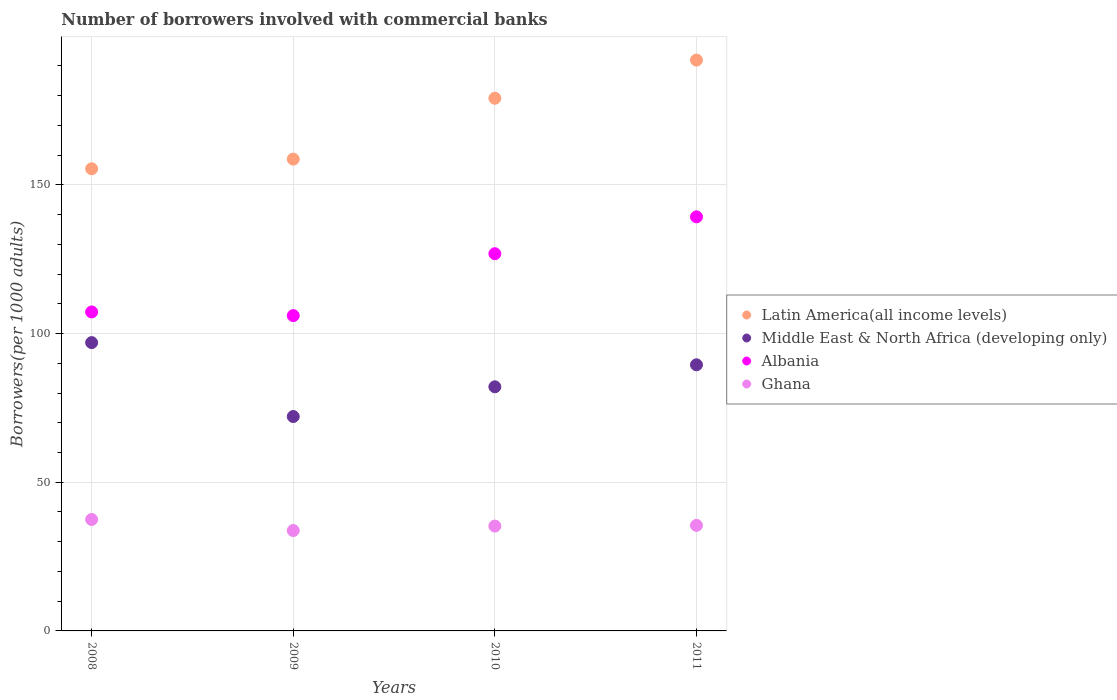How many different coloured dotlines are there?
Make the answer very short. 4. Is the number of dotlines equal to the number of legend labels?
Your response must be concise. Yes. What is the number of borrowers involved with commercial banks in Albania in 2011?
Your response must be concise. 139.27. Across all years, what is the maximum number of borrowers involved with commercial banks in Middle East & North Africa (developing only)?
Ensure brevity in your answer.  96.96. Across all years, what is the minimum number of borrowers involved with commercial banks in Middle East & North Africa (developing only)?
Offer a terse response. 72.11. What is the total number of borrowers involved with commercial banks in Middle East & North Africa (developing only) in the graph?
Make the answer very short. 340.67. What is the difference between the number of borrowers involved with commercial banks in Ghana in 2008 and that in 2011?
Offer a terse response. 1.98. What is the difference between the number of borrowers involved with commercial banks in Albania in 2010 and the number of borrowers involved with commercial banks in Latin America(all income levels) in 2009?
Make the answer very short. -31.82. What is the average number of borrowers involved with commercial banks in Ghana per year?
Your response must be concise. 35.5. In the year 2011, what is the difference between the number of borrowers involved with commercial banks in Albania and number of borrowers involved with commercial banks in Middle East & North Africa (developing only)?
Make the answer very short. 49.77. What is the ratio of the number of borrowers involved with commercial banks in Ghana in 2010 to that in 2011?
Ensure brevity in your answer.  0.99. Is the difference between the number of borrowers involved with commercial banks in Albania in 2010 and 2011 greater than the difference between the number of borrowers involved with commercial banks in Middle East & North Africa (developing only) in 2010 and 2011?
Provide a short and direct response. No. What is the difference between the highest and the second highest number of borrowers involved with commercial banks in Middle East & North Africa (developing only)?
Your answer should be compact. 7.46. What is the difference between the highest and the lowest number of borrowers involved with commercial banks in Latin America(all income levels)?
Your answer should be very brief. 36.55. In how many years, is the number of borrowers involved with commercial banks in Ghana greater than the average number of borrowers involved with commercial banks in Ghana taken over all years?
Offer a terse response. 1. Is it the case that in every year, the sum of the number of borrowers involved with commercial banks in Albania and number of borrowers involved with commercial banks in Latin America(all income levels)  is greater than the number of borrowers involved with commercial banks in Ghana?
Provide a short and direct response. Yes. Is the number of borrowers involved with commercial banks in Middle East & North Africa (developing only) strictly greater than the number of borrowers involved with commercial banks in Ghana over the years?
Ensure brevity in your answer.  Yes. Is the number of borrowers involved with commercial banks in Latin America(all income levels) strictly less than the number of borrowers involved with commercial banks in Ghana over the years?
Provide a short and direct response. No. What is the title of the graph?
Your response must be concise. Number of borrowers involved with commercial banks. What is the label or title of the Y-axis?
Your answer should be very brief. Borrowers(per 1000 adults). What is the Borrowers(per 1000 adults) in Latin America(all income levels) in 2008?
Your response must be concise. 155.43. What is the Borrowers(per 1000 adults) in Middle East & North Africa (developing only) in 2008?
Offer a very short reply. 96.96. What is the Borrowers(per 1000 adults) in Albania in 2008?
Your response must be concise. 107.27. What is the Borrowers(per 1000 adults) in Ghana in 2008?
Ensure brevity in your answer.  37.48. What is the Borrowers(per 1000 adults) in Latin America(all income levels) in 2009?
Offer a very short reply. 158.68. What is the Borrowers(per 1000 adults) of Middle East & North Africa (developing only) in 2009?
Give a very brief answer. 72.11. What is the Borrowers(per 1000 adults) of Albania in 2009?
Your answer should be very brief. 106.05. What is the Borrowers(per 1000 adults) of Ghana in 2009?
Your answer should be compact. 33.76. What is the Borrowers(per 1000 adults) in Latin America(all income levels) in 2010?
Your answer should be compact. 179.15. What is the Borrowers(per 1000 adults) in Middle East & North Africa (developing only) in 2010?
Give a very brief answer. 82.1. What is the Borrowers(per 1000 adults) of Albania in 2010?
Give a very brief answer. 126.87. What is the Borrowers(per 1000 adults) in Ghana in 2010?
Provide a succinct answer. 35.26. What is the Borrowers(per 1000 adults) of Latin America(all income levels) in 2011?
Ensure brevity in your answer.  191.98. What is the Borrowers(per 1000 adults) of Middle East & North Africa (developing only) in 2011?
Give a very brief answer. 89.5. What is the Borrowers(per 1000 adults) of Albania in 2011?
Give a very brief answer. 139.27. What is the Borrowers(per 1000 adults) of Ghana in 2011?
Ensure brevity in your answer.  35.5. Across all years, what is the maximum Borrowers(per 1000 adults) in Latin America(all income levels)?
Keep it short and to the point. 191.98. Across all years, what is the maximum Borrowers(per 1000 adults) in Middle East & North Africa (developing only)?
Your answer should be compact. 96.96. Across all years, what is the maximum Borrowers(per 1000 adults) in Albania?
Give a very brief answer. 139.27. Across all years, what is the maximum Borrowers(per 1000 adults) of Ghana?
Your answer should be very brief. 37.48. Across all years, what is the minimum Borrowers(per 1000 adults) in Latin America(all income levels)?
Keep it short and to the point. 155.43. Across all years, what is the minimum Borrowers(per 1000 adults) in Middle East & North Africa (developing only)?
Give a very brief answer. 72.11. Across all years, what is the minimum Borrowers(per 1000 adults) in Albania?
Provide a succinct answer. 106.05. Across all years, what is the minimum Borrowers(per 1000 adults) of Ghana?
Give a very brief answer. 33.76. What is the total Borrowers(per 1000 adults) of Latin America(all income levels) in the graph?
Give a very brief answer. 685.25. What is the total Borrowers(per 1000 adults) of Middle East & North Africa (developing only) in the graph?
Offer a terse response. 340.67. What is the total Borrowers(per 1000 adults) in Albania in the graph?
Provide a succinct answer. 479.45. What is the total Borrowers(per 1000 adults) in Ghana in the graph?
Offer a terse response. 142. What is the difference between the Borrowers(per 1000 adults) of Latin America(all income levels) in 2008 and that in 2009?
Your answer should be compact. -3.25. What is the difference between the Borrowers(per 1000 adults) of Middle East & North Africa (developing only) in 2008 and that in 2009?
Your answer should be compact. 24.86. What is the difference between the Borrowers(per 1000 adults) in Albania in 2008 and that in 2009?
Give a very brief answer. 1.23. What is the difference between the Borrowers(per 1000 adults) in Ghana in 2008 and that in 2009?
Offer a terse response. 3.72. What is the difference between the Borrowers(per 1000 adults) in Latin America(all income levels) in 2008 and that in 2010?
Your answer should be very brief. -23.72. What is the difference between the Borrowers(per 1000 adults) in Middle East & North Africa (developing only) in 2008 and that in 2010?
Offer a very short reply. 14.86. What is the difference between the Borrowers(per 1000 adults) in Albania in 2008 and that in 2010?
Your answer should be very brief. -19.59. What is the difference between the Borrowers(per 1000 adults) in Ghana in 2008 and that in 2010?
Make the answer very short. 2.22. What is the difference between the Borrowers(per 1000 adults) of Latin America(all income levels) in 2008 and that in 2011?
Provide a short and direct response. -36.55. What is the difference between the Borrowers(per 1000 adults) in Middle East & North Africa (developing only) in 2008 and that in 2011?
Your answer should be very brief. 7.46. What is the difference between the Borrowers(per 1000 adults) of Albania in 2008 and that in 2011?
Provide a short and direct response. -31.99. What is the difference between the Borrowers(per 1000 adults) in Ghana in 2008 and that in 2011?
Make the answer very short. 1.98. What is the difference between the Borrowers(per 1000 adults) in Latin America(all income levels) in 2009 and that in 2010?
Ensure brevity in your answer.  -20.47. What is the difference between the Borrowers(per 1000 adults) of Middle East & North Africa (developing only) in 2009 and that in 2010?
Make the answer very short. -10. What is the difference between the Borrowers(per 1000 adults) of Albania in 2009 and that in 2010?
Your answer should be compact. -20.82. What is the difference between the Borrowers(per 1000 adults) in Ghana in 2009 and that in 2010?
Ensure brevity in your answer.  -1.5. What is the difference between the Borrowers(per 1000 adults) of Latin America(all income levels) in 2009 and that in 2011?
Give a very brief answer. -33.3. What is the difference between the Borrowers(per 1000 adults) in Middle East & North Africa (developing only) in 2009 and that in 2011?
Give a very brief answer. -17.4. What is the difference between the Borrowers(per 1000 adults) in Albania in 2009 and that in 2011?
Your response must be concise. -33.22. What is the difference between the Borrowers(per 1000 adults) in Ghana in 2009 and that in 2011?
Make the answer very short. -1.74. What is the difference between the Borrowers(per 1000 adults) of Latin America(all income levels) in 2010 and that in 2011?
Keep it short and to the point. -12.83. What is the difference between the Borrowers(per 1000 adults) of Middle East & North Africa (developing only) in 2010 and that in 2011?
Provide a succinct answer. -7.4. What is the difference between the Borrowers(per 1000 adults) in Albania in 2010 and that in 2011?
Provide a short and direct response. -12.4. What is the difference between the Borrowers(per 1000 adults) in Ghana in 2010 and that in 2011?
Provide a succinct answer. -0.24. What is the difference between the Borrowers(per 1000 adults) of Latin America(all income levels) in 2008 and the Borrowers(per 1000 adults) of Middle East & North Africa (developing only) in 2009?
Ensure brevity in your answer.  83.33. What is the difference between the Borrowers(per 1000 adults) of Latin America(all income levels) in 2008 and the Borrowers(per 1000 adults) of Albania in 2009?
Your answer should be very brief. 49.39. What is the difference between the Borrowers(per 1000 adults) in Latin America(all income levels) in 2008 and the Borrowers(per 1000 adults) in Ghana in 2009?
Offer a terse response. 121.67. What is the difference between the Borrowers(per 1000 adults) in Middle East & North Africa (developing only) in 2008 and the Borrowers(per 1000 adults) in Albania in 2009?
Your response must be concise. -9.08. What is the difference between the Borrowers(per 1000 adults) in Middle East & North Africa (developing only) in 2008 and the Borrowers(per 1000 adults) in Ghana in 2009?
Make the answer very short. 63.2. What is the difference between the Borrowers(per 1000 adults) of Albania in 2008 and the Borrowers(per 1000 adults) of Ghana in 2009?
Your answer should be compact. 73.51. What is the difference between the Borrowers(per 1000 adults) of Latin America(all income levels) in 2008 and the Borrowers(per 1000 adults) of Middle East & North Africa (developing only) in 2010?
Provide a short and direct response. 73.33. What is the difference between the Borrowers(per 1000 adults) in Latin America(all income levels) in 2008 and the Borrowers(per 1000 adults) in Albania in 2010?
Your response must be concise. 28.57. What is the difference between the Borrowers(per 1000 adults) in Latin America(all income levels) in 2008 and the Borrowers(per 1000 adults) in Ghana in 2010?
Offer a very short reply. 120.17. What is the difference between the Borrowers(per 1000 adults) in Middle East & North Africa (developing only) in 2008 and the Borrowers(per 1000 adults) in Albania in 2010?
Offer a very short reply. -29.9. What is the difference between the Borrowers(per 1000 adults) in Middle East & North Africa (developing only) in 2008 and the Borrowers(per 1000 adults) in Ghana in 2010?
Provide a succinct answer. 61.7. What is the difference between the Borrowers(per 1000 adults) in Albania in 2008 and the Borrowers(per 1000 adults) in Ghana in 2010?
Your answer should be very brief. 72.01. What is the difference between the Borrowers(per 1000 adults) in Latin America(all income levels) in 2008 and the Borrowers(per 1000 adults) in Middle East & North Africa (developing only) in 2011?
Ensure brevity in your answer.  65.93. What is the difference between the Borrowers(per 1000 adults) in Latin America(all income levels) in 2008 and the Borrowers(per 1000 adults) in Albania in 2011?
Your answer should be compact. 16.17. What is the difference between the Borrowers(per 1000 adults) in Latin America(all income levels) in 2008 and the Borrowers(per 1000 adults) in Ghana in 2011?
Your answer should be compact. 119.93. What is the difference between the Borrowers(per 1000 adults) in Middle East & North Africa (developing only) in 2008 and the Borrowers(per 1000 adults) in Albania in 2011?
Your answer should be very brief. -42.3. What is the difference between the Borrowers(per 1000 adults) of Middle East & North Africa (developing only) in 2008 and the Borrowers(per 1000 adults) of Ghana in 2011?
Your response must be concise. 61.46. What is the difference between the Borrowers(per 1000 adults) in Albania in 2008 and the Borrowers(per 1000 adults) in Ghana in 2011?
Your response must be concise. 71.77. What is the difference between the Borrowers(per 1000 adults) of Latin America(all income levels) in 2009 and the Borrowers(per 1000 adults) of Middle East & North Africa (developing only) in 2010?
Provide a short and direct response. 76.58. What is the difference between the Borrowers(per 1000 adults) in Latin America(all income levels) in 2009 and the Borrowers(per 1000 adults) in Albania in 2010?
Provide a succinct answer. 31.82. What is the difference between the Borrowers(per 1000 adults) of Latin America(all income levels) in 2009 and the Borrowers(per 1000 adults) of Ghana in 2010?
Keep it short and to the point. 123.42. What is the difference between the Borrowers(per 1000 adults) in Middle East & North Africa (developing only) in 2009 and the Borrowers(per 1000 adults) in Albania in 2010?
Give a very brief answer. -54.76. What is the difference between the Borrowers(per 1000 adults) in Middle East & North Africa (developing only) in 2009 and the Borrowers(per 1000 adults) in Ghana in 2010?
Your answer should be compact. 36.85. What is the difference between the Borrowers(per 1000 adults) in Albania in 2009 and the Borrowers(per 1000 adults) in Ghana in 2010?
Offer a terse response. 70.79. What is the difference between the Borrowers(per 1000 adults) of Latin America(all income levels) in 2009 and the Borrowers(per 1000 adults) of Middle East & North Africa (developing only) in 2011?
Your response must be concise. 69.18. What is the difference between the Borrowers(per 1000 adults) in Latin America(all income levels) in 2009 and the Borrowers(per 1000 adults) in Albania in 2011?
Ensure brevity in your answer.  19.42. What is the difference between the Borrowers(per 1000 adults) in Latin America(all income levels) in 2009 and the Borrowers(per 1000 adults) in Ghana in 2011?
Ensure brevity in your answer.  123.18. What is the difference between the Borrowers(per 1000 adults) in Middle East & North Africa (developing only) in 2009 and the Borrowers(per 1000 adults) in Albania in 2011?
Provide a succinct answer. -67.16. What is the difference between the Borrowers(per 1000 adults) in Middle East & North Africa (developing only) in 2009 and the Borrowers(per 1000 adults) in Ghana in 2011?
Offer a very short reply. 36.61. What is the difference between the Borrowers(per 1000 adults) of Albania in 2009 and the Borrowers(per 1000 adults) of Ghana in 2011?
Offer a very short reply. 70.55. What is the difference between the Borrowers(per 1000 adults) of Latin America(all income levels) in 2010 and the Borrowers(per 1000 adults) of Middle East & North Africa (developing only) in 2011?
Offer a very short reply. 89.65. What is the difference between the Borrowers(per 1000 adults) in Latin America(all income levels) in 2010 and the Borrowers(per 1000 adults) in Albania in 2011?
Provide a short and direct response. 39.88. What is the difference between the Borrowers(per 1000 adults) in Latin America(all income levels) in 2010 and the Borrowers(per 1000 adults) in Ghana in 2011?
Provide a short and direct response. 143.65. What is the difference between the Borrowers(per 1000 adults) of Middle East & North Africa (developing only) in 2010 and the Borrowers(per 1000 adults) of Albania in 2011?
Make the answer very short. -57.16. What is the difference between the Borrowers(per 1000 adults) in Middle East & North Africa (developing only) in 2010 and the Borrowers(per 1000 adults) in Ghana in 2011?
Ensure brevity in your answer.  46.6. What is the difference between the Borrowers(per 1000 adults) in Albania in 2010 and the Borrowers(per 1000 adults) in Ghana in 2011?
Give a very brief answer. 91.37. What is the average Borrowers(per 1000 adults) of Latin America(all income levels) per year?
Your response must be concise. 171.31. What is the average Borrowers(per 1000 adults) in Middle East & North Africa (developing only) per year?
Give a very brief answer. 85.17. What is the average Borrowers(per 1000 adults) of Albania per year?
Keep it short and to the point. 119.86. What is the average Borrowers(per 1000 adults) of Ghana per year?
Your answer should be compact. 35.5. In the year 2008, what is the difference between the Borrowers(per 1000 adults) of Latin America(all income levels) and Borrowers(per 1000 adults) of Middle East & North Africa (developing only)?
Give a very brief answer. 58.47. In the year 2008, what is the difference between the Borrowers(per 1000 adults) of Latin America(all income levels) and Borrowers(per 1000 adults) of Albania?
Ensure brevity in your answer.  48.16. In the year 2008, what is the difference between the Borrowers(per 1000 adults) in Latin America(all income levels) and Borrowers(per 1000 adults) in Ghana?
Provide a short and direct response. 117.95. In the year 2008, what is the difference between the Borrowers(per 1000 adults) in Middle East & North Africa (developing only) and Borrowers(per 1000 adults) in Albania?
Offer a terse response. -10.31. In the year 2008, what is the difference between the Borrowers(per 1000 adults) in Middle East & North Africa (developing only) and Borrowers(per 1000 adults) in Ghana?
Your answer should be very brief. 59.48. In the year 2008, what is the difference between the Borrowers(per 1000 adults) of Albania and Borrowers(per 1000 adults) of Ghana?
Offer a very short reply. 69.79. In the year 2009, what is the difference between the Borrowers(per 1000 adults) of Latin America(all income levels) and Borrowers(per 1000 adults) of Middle East & North Africa (developing only)?
Your answer should be compact. 86.58. In the year 2009, what is the difference between the Borrowers(per 1000 adults) in Latin America(all income levels) and Borrowers(per 1000 adults) in Albania?
Offer a very short reply. 52.64. In the year 2009, what is the difference between the Borrowers(per 1000 adults) of Latin America(all income levels) and Borrowers(per 1000 adults) of Ghana?
Provide a short and direct response. 124.92. In the year 2009, what is the difference between the Borrowers(per 1000 adults) of Middle East & North Africa (developing only) and Borrowers(per 1000 adults) of Albania?
Offer a very short reply. -33.94. In the year 2009, what is the difference between the Borrowers(per 1000 adults) of Middle East & North Africa (developing only) and Borrowers(per 1000 adults) of Ghana?
Offer a terse response. 38.34. In the year 2009, what is the difference between the Borrowers(per 1000 adults) of Albania and Borrowers(per 1000 adults) of Ghana?
Your response must be concise. 72.28. In the year 2010, what is the difference between the Borrowers(per 1000 adults) of Latin America(all income levels) and Borrowers(per 1000 adults) of Middle East & North Africa (developing only)?
Your response must be concise. 97.05. In the year 2010, what is the difference between the Borrowers(per 1000 adults) of Latin America(all income levels) and Borrowers(per 1000 adults) of Albania?
Ensure brevity in your answer.  52.28. In the year 2010, what is the difference between the Borrowers(per 1000 adults) in Latin America(all income levels) and Borrowers(per 1000 adults) in Ghana?
Keep it short and to the point. 143.89. In the year 2010, what is the difference between the Borrowers(per 1000 adults) of Middle East & North Africa (developing only) and Borrowers(per 1000 adults) of Albania?
Ensure brevity in your answer.  -44.77. In the year 2010, what is the difference between the Borrowers(per 1000 adults) of Middle East & North Africa (developing only) and Borrowers(per 1000 adults) of Ghana?
Your answer should be compact. 46.84. In the year 2010, what is the difference between the Borrowers(per 1000 adults) of Albania and Borrowers(per 1000 adults) of Ghana?
Your response must be concise. 91.61. In the year 2011, what is the difference between the Borrowers(per 1000 adults) of Latin America(all income levels) and Borrowers(per 1000 adults) of Middle East & North Africa (developing only)?
Give a very brief answer. 102.48. In the year 2011, what is the difference between the Borrowers(per 1000 adults) of Latin America(all income levels) and Borrowers(per 1000 adults) of Albania?
Make the answer very short. 52.72. In the year 2011, what is the difference between the Borrowers(per 1000 adults) in Latin America(all income levels) and Borrowers(per 1000 adults) in Ghana?
Your answer should be very brief. 156.48. In the year 2011, what is the difference between the Borrowers(per 1000 adults) in Middle East & North Africa (developing only) and Borrowers(per 1000 adults) in Albania?
Give a very brief answer. -49.77. In the year 2011, what is the difference between the Borrowers(per 1000 adults) in Middle East & North Africa (developing only) and Borrowers(per 1000 adults) in Ghana?
Make the answer very short. 54. In the year 2011, what is the difference between the Borrowers(per 1000 adults) in Albania and Borrowers(per 1000 adults) in Ghana?
Provide a short and direct response. 103.77. What is the ratio of the Borrowers(per 1000 adults) in Latin America(all income levels) in 2008 to that in 2009?
Your response must be concise. 0.98. What is the ratio of the Borrowers(per 1000 adults) of Middle East & North Africa (developing only) in 2008 to that in 2009?
Keep it short and to the point. 1.34. What is the ratio of the Borrowers(per 1000 adults) in Albania in 2008 to that in 2009?
Your response must be concise. 1.01. What is the ratio of the Borrowers(per 1000 adults) of Ghana in 2008 to that in 2009?
Your response must be concise. 1.11. What is the ratio of the Borrowers(per 1000 adults) in Latin America(all income levels) in 2008 to that in 2010?
Provide a short and direct response. 0.87. What is the ratio of the Borrowers(per 1000 adults) of Middle East & North Africa (developing only) in 2008 to that in 2010?
Your answer should be very brief. 1.18. What is the ratio of the Borrowers(per 1000 adults) in Albania in 2008 to that in 2010?
Make the answer very short. 0.85. What is the ratio of the Borrowers(per 1000 adults) of Ghana in 2008 to that in 2010?
Your answer should be very brief. 1.06. What is the ratio of the Borrowers(per 1000 adults) of Latin America(all income levels) in 2008 to that in 2011?
Make the answer very short. 0.81. What is the ratio of the Borrowers(per 1000 adults) of Middle East & North Africa (developing only) in 2008 to that in 2011?
Give a very brief answer. 1.08. What is the ratio of the Borrowers(per 1000 adults) of Albania in 2008 to that in 2011?
Provide a succinct answer. 0.77. What is the ratio of the Borrowers(per 1000 adults) in Ghana in 2008 to that in 2011?
Your response must be concise. 1.06. What is the ratio of the Borrowers(per 1000 adults) of Latin America(all income levels) in 2009 to that in 2010?
Your answer should be very brief. 0.89. What is the ratio of the Borrowers(per 1000 adults) of Middle East & North Africa (developing only) in 2009 to that in 2010?
Provide a short and direct response. 0.88. What is the ratio of the Borrowers(per 1000 adults) of Albania in 2009 to that in 2010?
Your answer should be very brief. 0.84. What is the ratio of the Borrowers(per 1000 adults) in Ghana in 2009 to that in 2010?
Your answer should be very brief. 0.96. What is the ratio of the Borrowers(per 1000 adults) of Latin America(all income levels) in 2009 to that in 2011?
Your answer should be very brief. 0.83. What is the ratio of the Borrowers(per 1000 adults) of Middle East & North Africa (developing only) in 2009 to that in 2011?
Provide a succinct answer. 0.81. What is the ratio of the Borrowers(per 1000 adults) in Albania in 2009 to that in 2011?
Make the answer very short. 0.76. What is the ratio of the Borrowers(per 1000 adults) of Ghana in 2009 to that in 2011?
Ensure brevity in your answer.  0.95. What is the ratio of the Borrowers(per 1000 adults) in Latin America(all income levels) in 2010 to that in 2011?
Offer a very short reply. 0.93. What is the ratio of the Borrowers(per 1000 adults) in Middle East & North Africa (developing only) in 2010 to that in 2011?
Offer a very short reply. 0.92. What is the ratio of the Borrowers(per 1000 adults) of Albania in 2010 to that in 2011?
Give a very brief answer. 0.91. What is the difference between the highest and the second highest Borrowers(per 1000 adults) of Latin America(all income levels)?
Give a very brief answer. 12.83. What is the difference between the highest and the second highest Borrowers(per 1000 adults) in Middle East & North Africa (developing only)?
Ensure brevity in your answer.  7.46. What is the difference between the highest and the second highest Borrowers(per 1000 adults) in Albania?
Offer a terse response. 12.4. What is the difference between the highest and the second highest Borrowers(per 1000 adults) of Ghana?
Provide a succinct answer. 1.98. What is the difference between the highest and the lowest Borrowers(per 1000 adults) in Latin America(all income levels)?
Give a very brief answer. 36.55. What is the difference between the highest and the lowest Borrowers(per 1000 adults) of Middle East & North Africa (developing only)?
Your response must be concise. 24.86. What is the difference between the highest and the lowest Borrowers(per 1000 adults) of Albania?
Give a very brief answer. 33.22. What is the difference between the highest and the lowest Borrowers(per 1000 adults) of Ghana?
Your answer should be very brief. 3.72. 